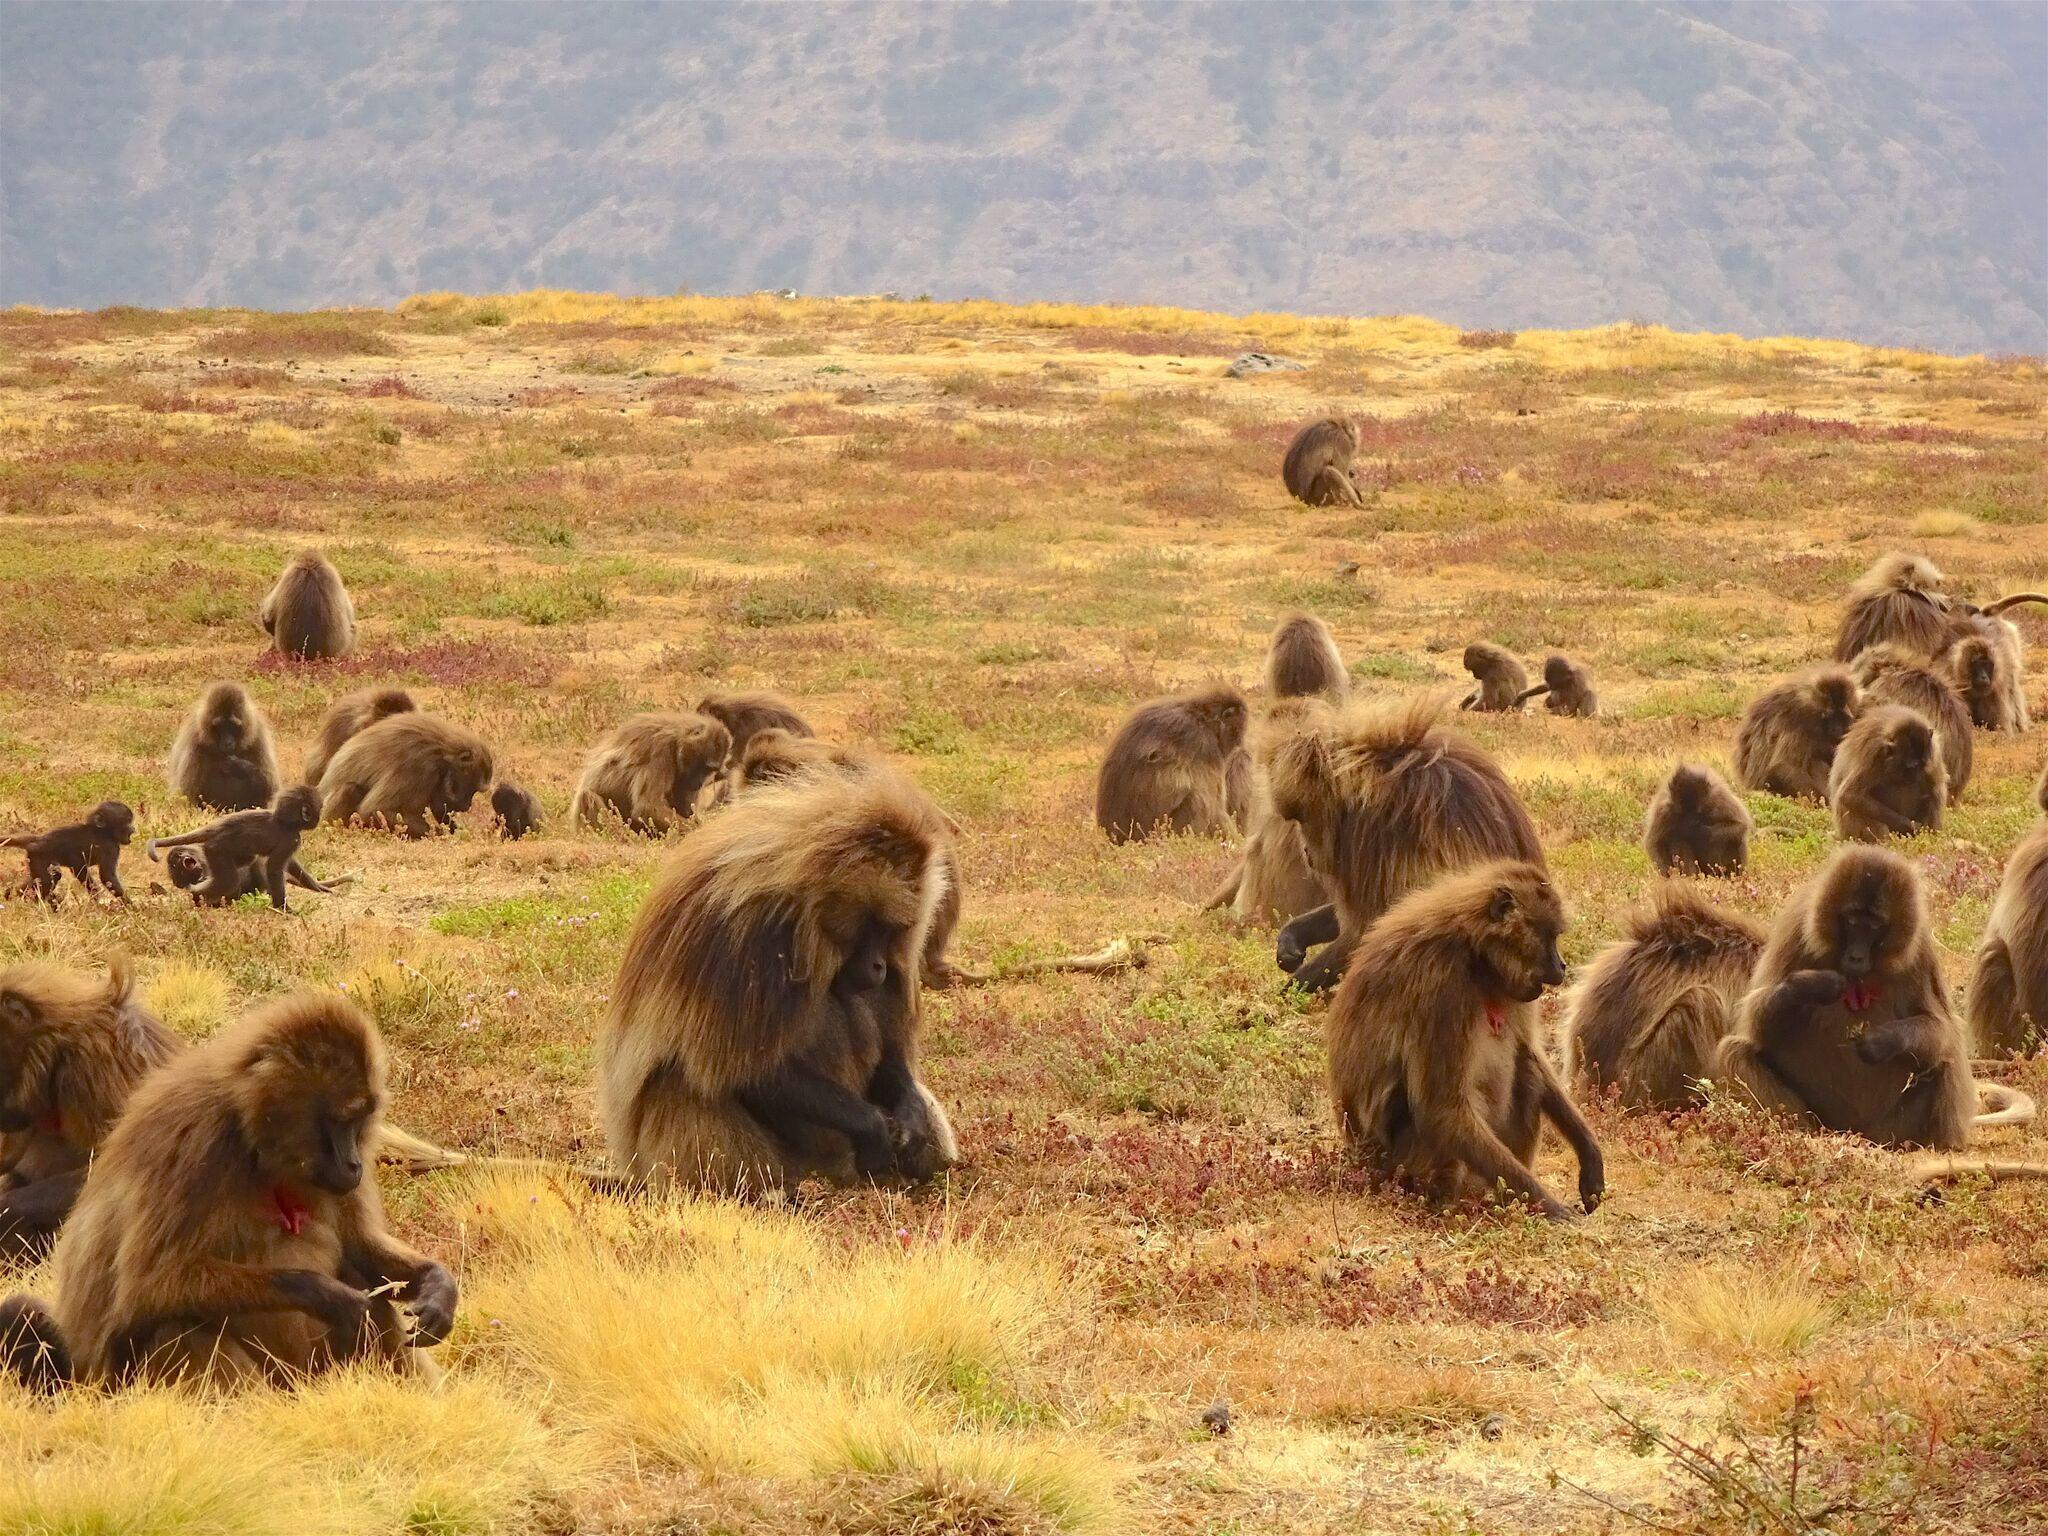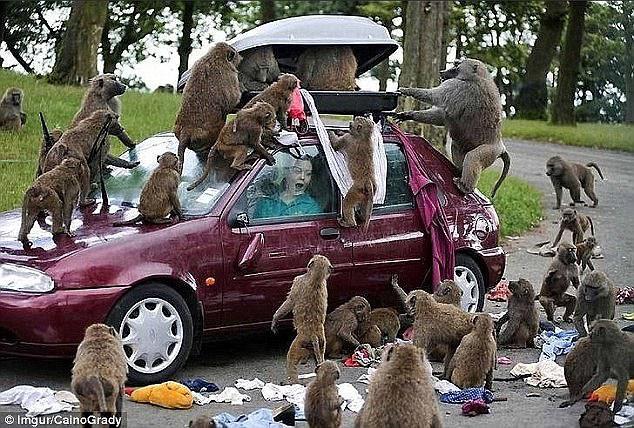The first image is the image on the left, the second image is the image on the right. Considering the images on both sides, is "Baboons are walking along a dirt path flanked by bushes and trees in one image." valid? Answer yes or no. No. The first image is the image on the left, the second image is the image on the right. Given the left and right images, does the statement "There are at most 3 baboons in the left image." hold true? Answer yes or no. No. 